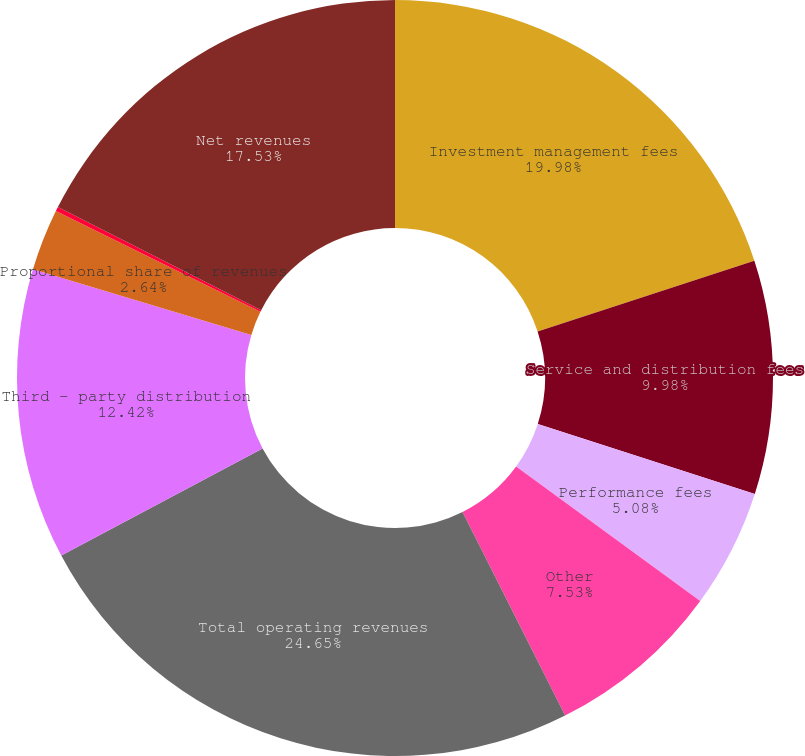Convert chart. <chart><loc_0><loc_0><loc_500><loc_500><pie_chart><fcel>Investment management fees<fcel>Service and distribution fees<fcel>Performance fees<fcel>Other<fcel>Total operating revenues<fcel>Third - party distribution<fcel>Proportional share of revenues<fcel>CIP<fcel>Net revenues<nl><fcel>19.98%<fcel>9.98%<fcel>5.08%<fcel>7.53%<fcel>24.65%<fcel>12.42%<fcel>2.64%<fcel>0.19%<fcel>17.53%<nl></chart> 